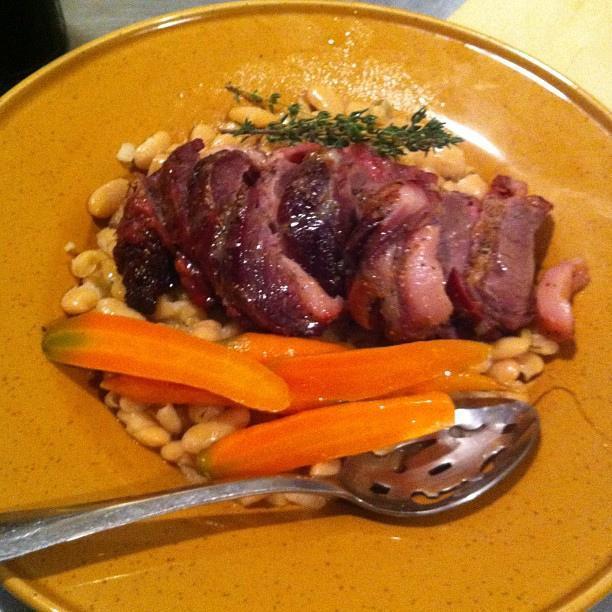How many carrots are there?
Give a very brief answer. 2. 